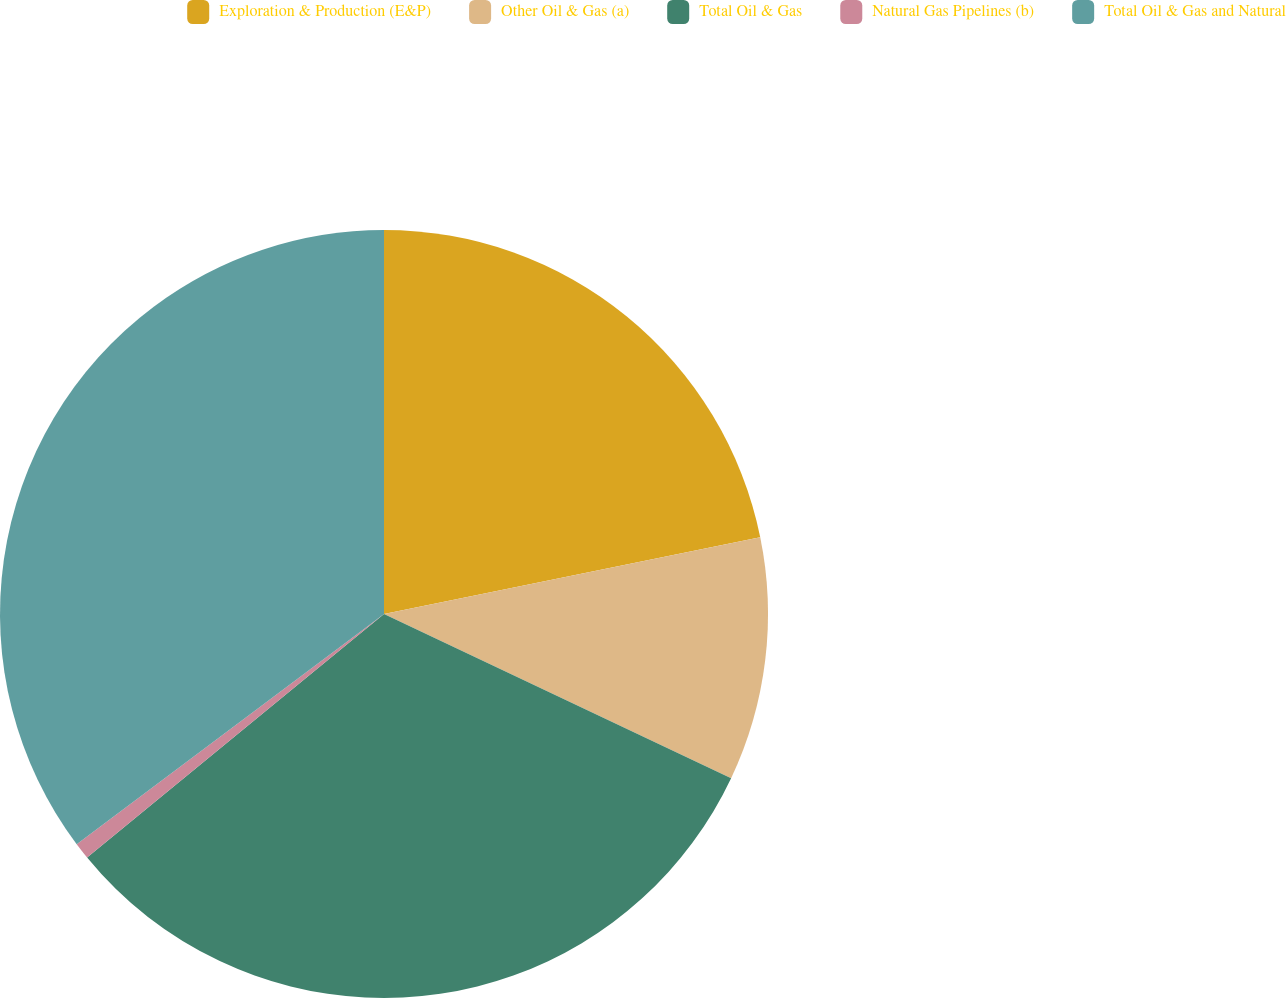Convert chart. <chart><loc_0><loc_0><loc_500><loc_500><pie_chart><fcel>Exploration & Production (E&P)<fcel>Other Oil & Gas (a)<fcel>Total Oil & Gas<fcel>Natural Gas Pipelines (b)<fcel>Total Oil & Gas and Natural<nl><fcel>21.79%<fcel>10.24%<fcel>32.03%<fcel>0.7%<fcel>35.23%<nl></chart> 